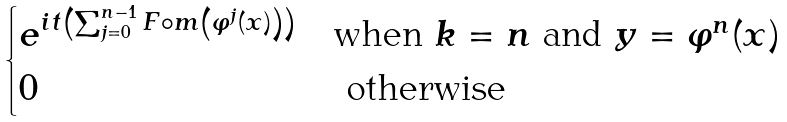<formula> <loc_0><loc_0><loc_500><loc_500>\begin{cases} e ^ { i t \left ( \sum _ { j = 0 } ^ { n - 1 } F \circ m \left ( \varphi ^ { j } ( x ) \right ) \right ) } & \text {when} \ k = n \ \text {and} \ y = \varphi ^ { n } ( x ) \\ 0 & \ \text {otherwise} \end{cases}</formula> 